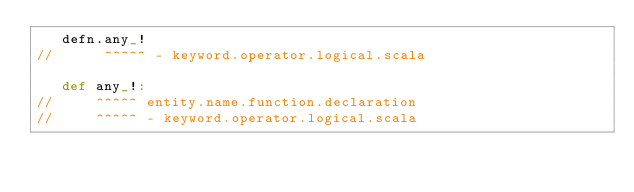<code> <loc_0><loc_0><loc_500><loc_500><_Scala_>   defn.any_!
//      ^^^^^ - keyword.operator.logical.scala

   def any_!:
//     ^^^^^ entity.name.function.declaration
//     ^^^^^ - keyword.operator.logical.scala</code> 